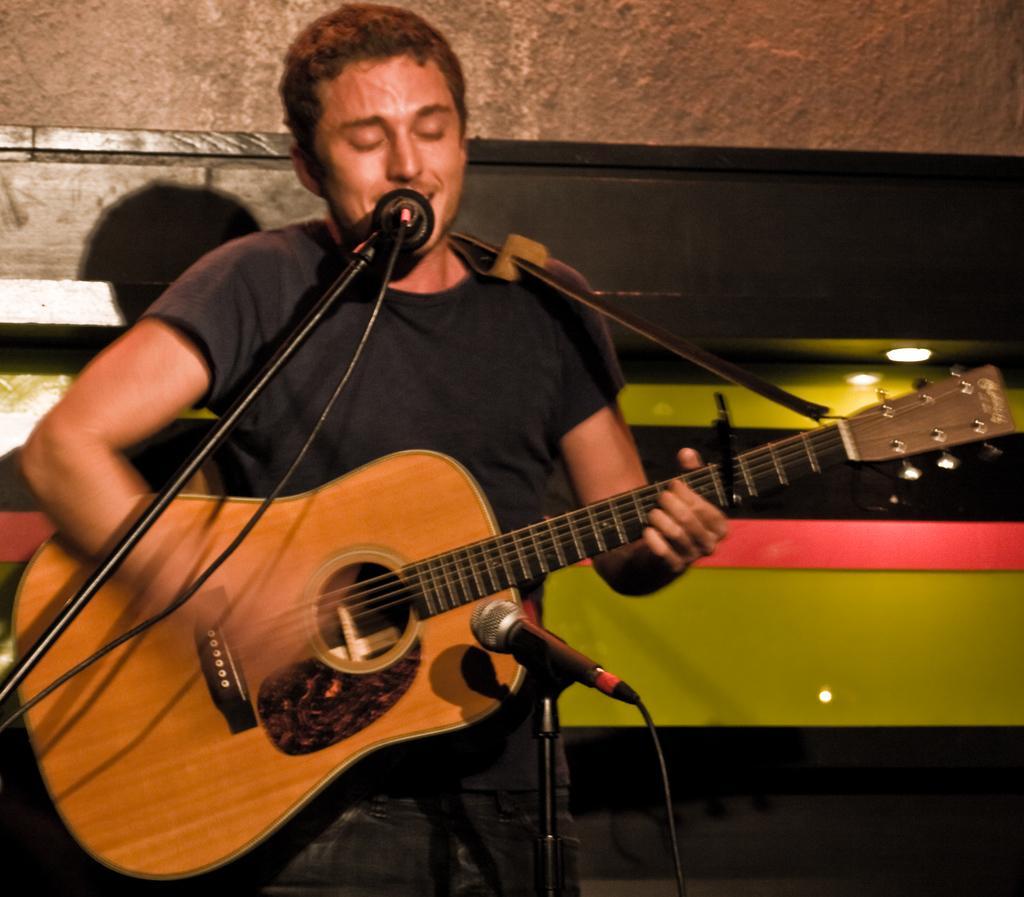Could you give a brief overview of what you see in this image? In the image we can see there is a man who is standing and holding guitar in his hand. 